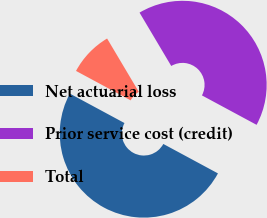<chart> <loc_0><loc_0><loc_500><loc_500><pie_chart><fcel>Net actuarial loss<fcel>Prior service cost (credit)<fcel>Total<nl><fcel>50.0%<fcel>41.4%<fcel>8.6%<nl></chart> 